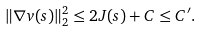Convert formula to latex. <formula><loc_0><loc_0><loc_500><loc_500>\| \nabla v ( s ) \| _ { 2 } ^ { 2 } \leq 2 J ( s ) + C \leq C ^ { \prime } .</formula> 